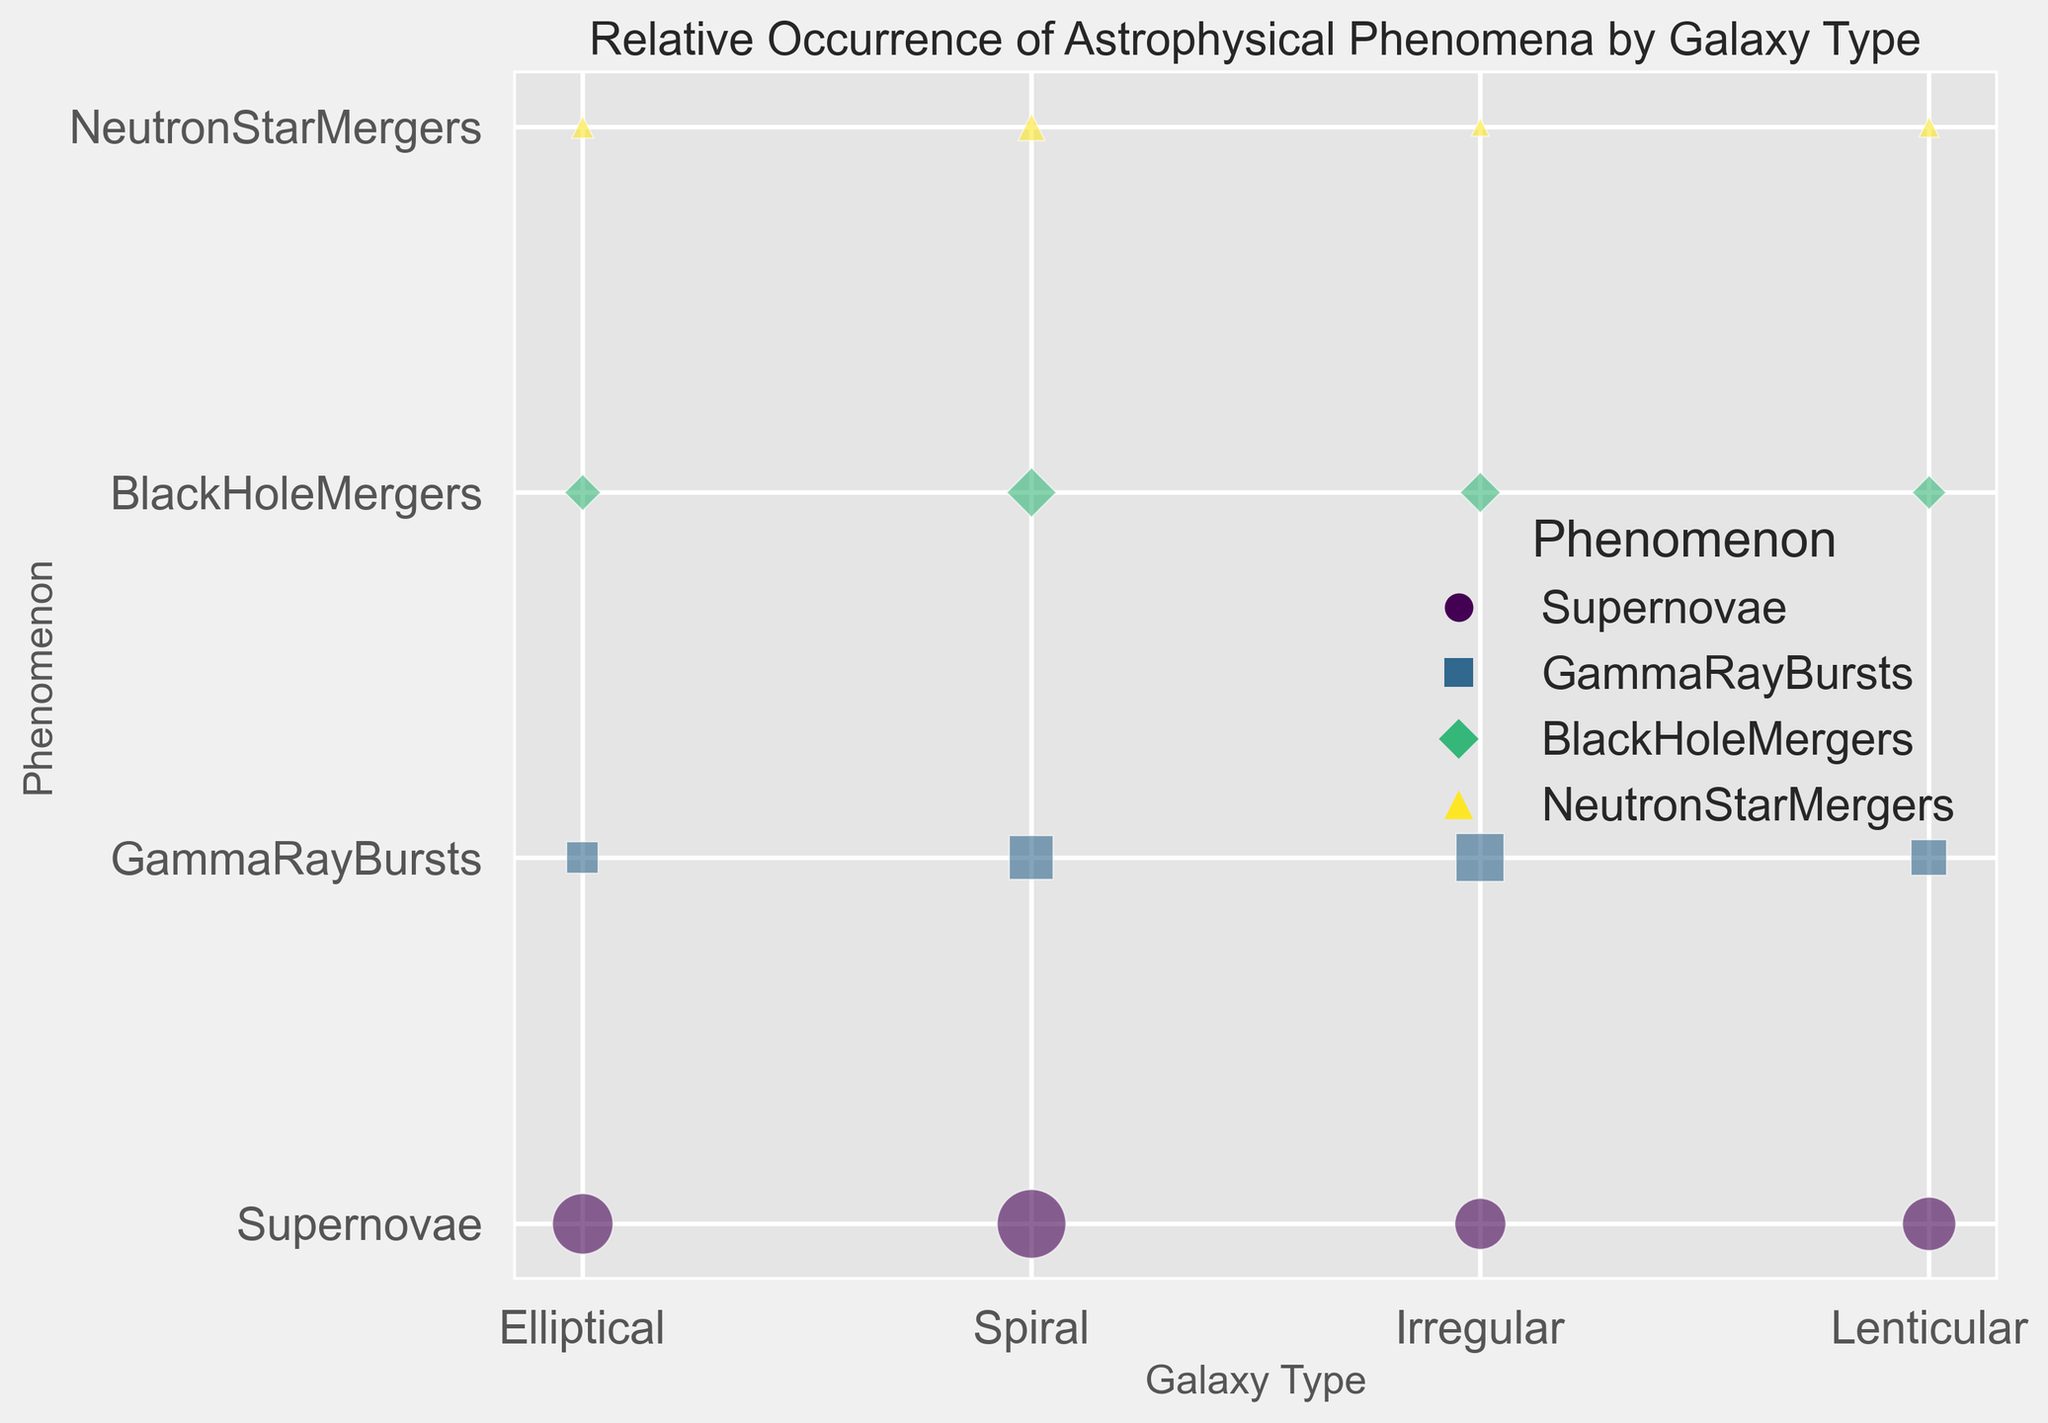Which galaxy type has the highest relative occurrence of supernovae? The chart shows that Spiral galaxies have the largest bubble for supernovae, indicating the highest relative occurrence.
Answer: Spiral Which phenomenon has the smallest relative occurrence in Irregular galaxies? The chart indicates that Neutron Star Mergers in Irregular galaxies have the smallest bubble size compared to other phenomena.
Answer: Neutron Star Mergers How does the occurrence of gamma-ray bursts in Elliptical galaxies compare to those in Lenticular galaxies? By comparing bubble sizes, gamma-ray bursts in Elliptical galaxies (1.2) are smaller than those in Lenticular galaxies (1.5).
Answer: Less In which galaxy type do black hole mergers have the highest occurrence? The chart reveals that Spiral galaxies have the largest bubble for black hole mergers, indicating the highest occurrence.
Answer: Spiral Which two phenomena have the closest relative occurrences in Elliptical galaxies? By examining the bubble sizes, Black Hole Mergers (0.8) and Neutron Star Mergers (0.6) in Elliptical galaxies are the closest in occurrence.
Answer: Black Hole Mergers and Neutron Star Mergers Which phenomenon shows a greater relative difference in occurrence between Spiral and Irregular galaxies? The occurrences of supernovae in Spiral (5.8) and Irregular (3.2) galaxies present a larger difference compared to other phenomena. Difference: 5.8 - 3.2 = 2.6.
Answer: Supernovae Is the occurrence of supernovae more frequent in Lenticular or Irregular galaxies? Comparing the bubble sizes, supernovae occurrence in Lenticular galaxies (3.5) is larger than in Irregular galaxies (3.2).
Answer: Lenticular What is the sum of the occurrences of gamma-ray bursts across all galaxy types? Summing the occurrences: Elliptical (1.2) + Spiral (2.3) + Irregular (2.8) + Lenticular (1.5) = 7.8.
Answer: 7.8 Which has a closer occurrence in Spiral galaxies, black hole mergers or neutron star mergers? By comparing the bubble sizes, black hole mergers (1.5) and neutron star mergers (0.9) in Spiral galaxies differ by 0.6. The relative size indicates that black hole mergers are closer.
Answer: Black Hole Mergers What is the average relative occurrence of the four phenomena in Lenticular galaxies? Summing occurrences: Supernovae (3.5) + GammaRayBursts (1.5) + BlackHoleMergers (0.7) + NeutronStarMergers (0.5) = 6.2. Average: 6.2 / 4 = 1.55.
Answer: 1.55 